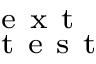Convert formula to latex. <formula><loc_0><loc_0><loc_500><loc_500>_ { t } e s t ^ { e x t }</formula> 